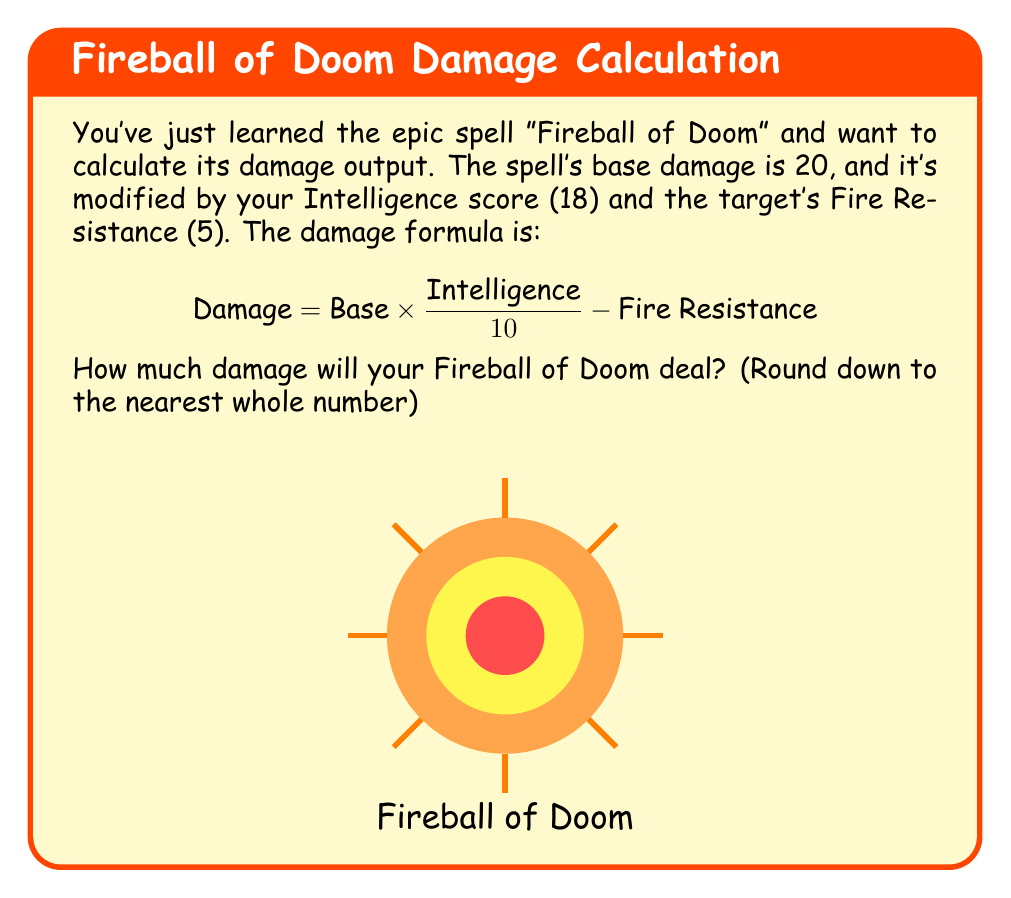Could you help me with this problem? Let's break this down step-by-step:

1) We're given:
   - Base damage = 20
   - Intelligence score = 18
   - Fire Resistance = 5

2) Let's plug these into our formula:

   $$ \text{Damage} = 20 \times \frac{18}{10} - 5 $$

3) First, let's calculate $\frac{18}{10}$:
   
   $$ \frac{18}{10} = 1.8 $$

4) Now, let's multiply the base damage by this value:

   $$ 20 \times 1.8 = 36 $$

5) Finally, we subtract the Fire Resistance:

   $$ 36 - 5 = 31 $$

6) The question asks us to round down to the nearest whole number, but 31 is already a whole number, so we're done!

Therefore, your Fireball of Doom will deal 31 damage.
Answer: 31 